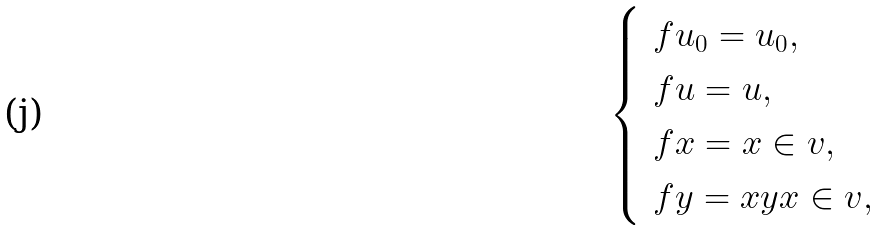Convert formula to latex. <formula><loc_0><loc_0><loc_500><loc_500>\begin{cases} \ f u _ { 0 } = u _ { 0 } , \\ \ f u = u , \\ \ f x = x \in v , \\ \ f y = x y x \in v , \end{cases}</formula> 